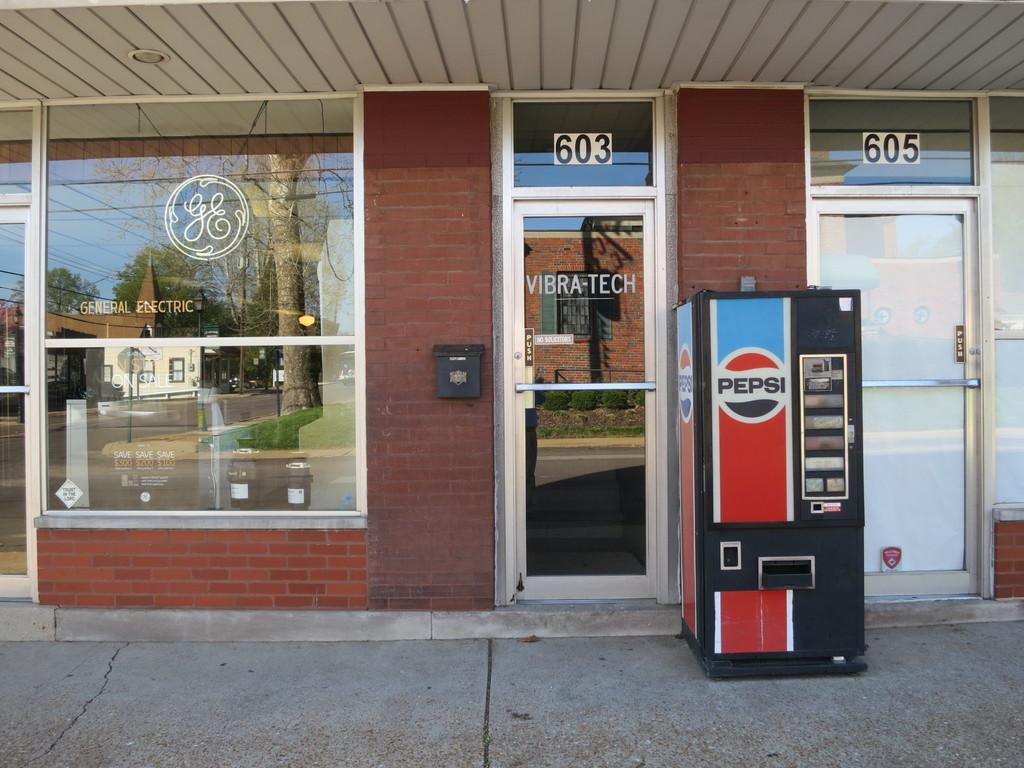What type of architectural feature can be seen in the image? There are doors in the image. What additional details can be found in the image? There are numbers, a machine, and reflections of a house and a tree on the glass. Can you describe the machine in the image? Unfortunately, the facts provided do not give a detailed description of the machine. What is the purpose of the numbers in the image? The facts provided do not specify the purpose of the numbers. What type of wine is being served in the image? There is no wine present in the image. How does the stone contribute to the overall aesthetic of the image? There is no stone present in the image. 